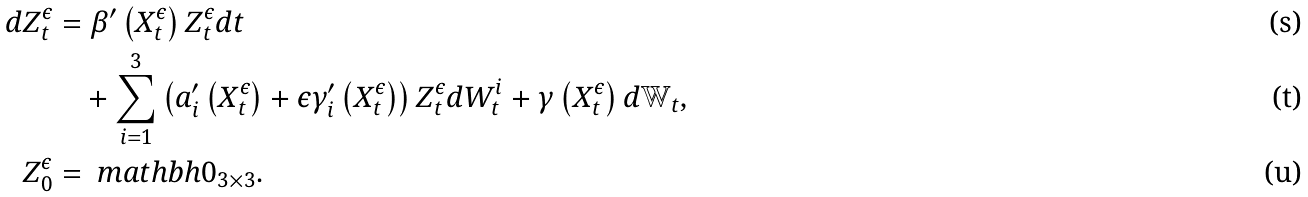<formula> <loc_0><loc_0><loc_500><loc_500>d Z _ { t } ^ { \epsilon } & = \beta ^ { \prime } \left ( X _ { t } ^ { \epsilon } \right ) Z _ { t } ^ { \epsilon } d t \\ & \quad + \sum _ { i = 1 } ^ { 3 } { \left ( a _ { i } ^ { \prime } \left ( X _ { t } ^ { \epsilon } \right ) + \epsilon \gamma _ { i } ^ { \prime } \left ( X _ { t } ^ { \epsilon } \right ) \right ) Z _ { t } ^ { \epsilon } d W _ { t } ^ { i } } + \gamma \left ( X _ { t } ^ { \epsilon } \right ) d \mathbb { W } _ { t } , \\ Z _ { 0 } ^ { \epsilon } & = \ m a t h b h { 0 } _ { 3 \times 3 } .</formula> 